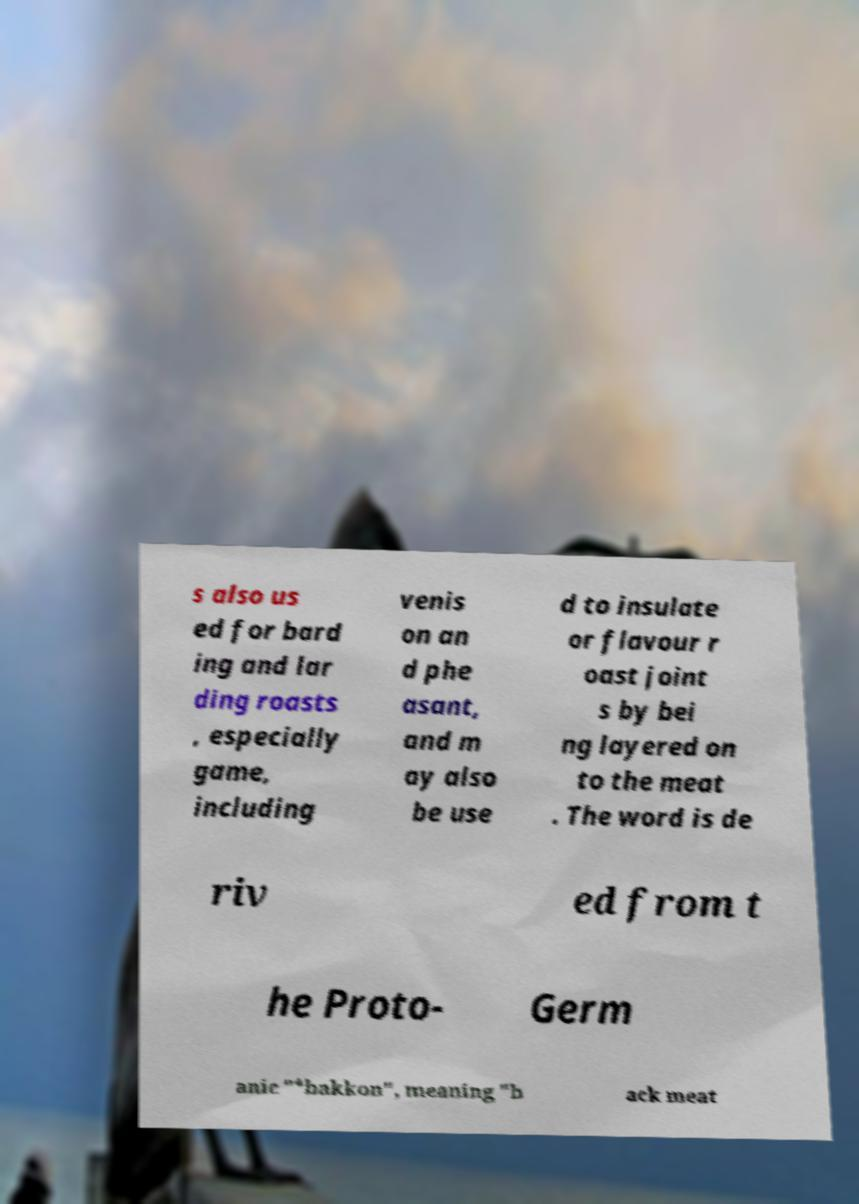There's text embedded in this image that I need extracted. Can you transcribe it verbatim? s also us ed for bard ing and lar ding roasts , especially game, including venis on an d phe asant, and m ay also be use d to insulate or flavour r oast joint s by bei ng layered on to the meat . The word is de riv ed from t he Proto- Germ anic "*bakkon", meaning "b ack meat 